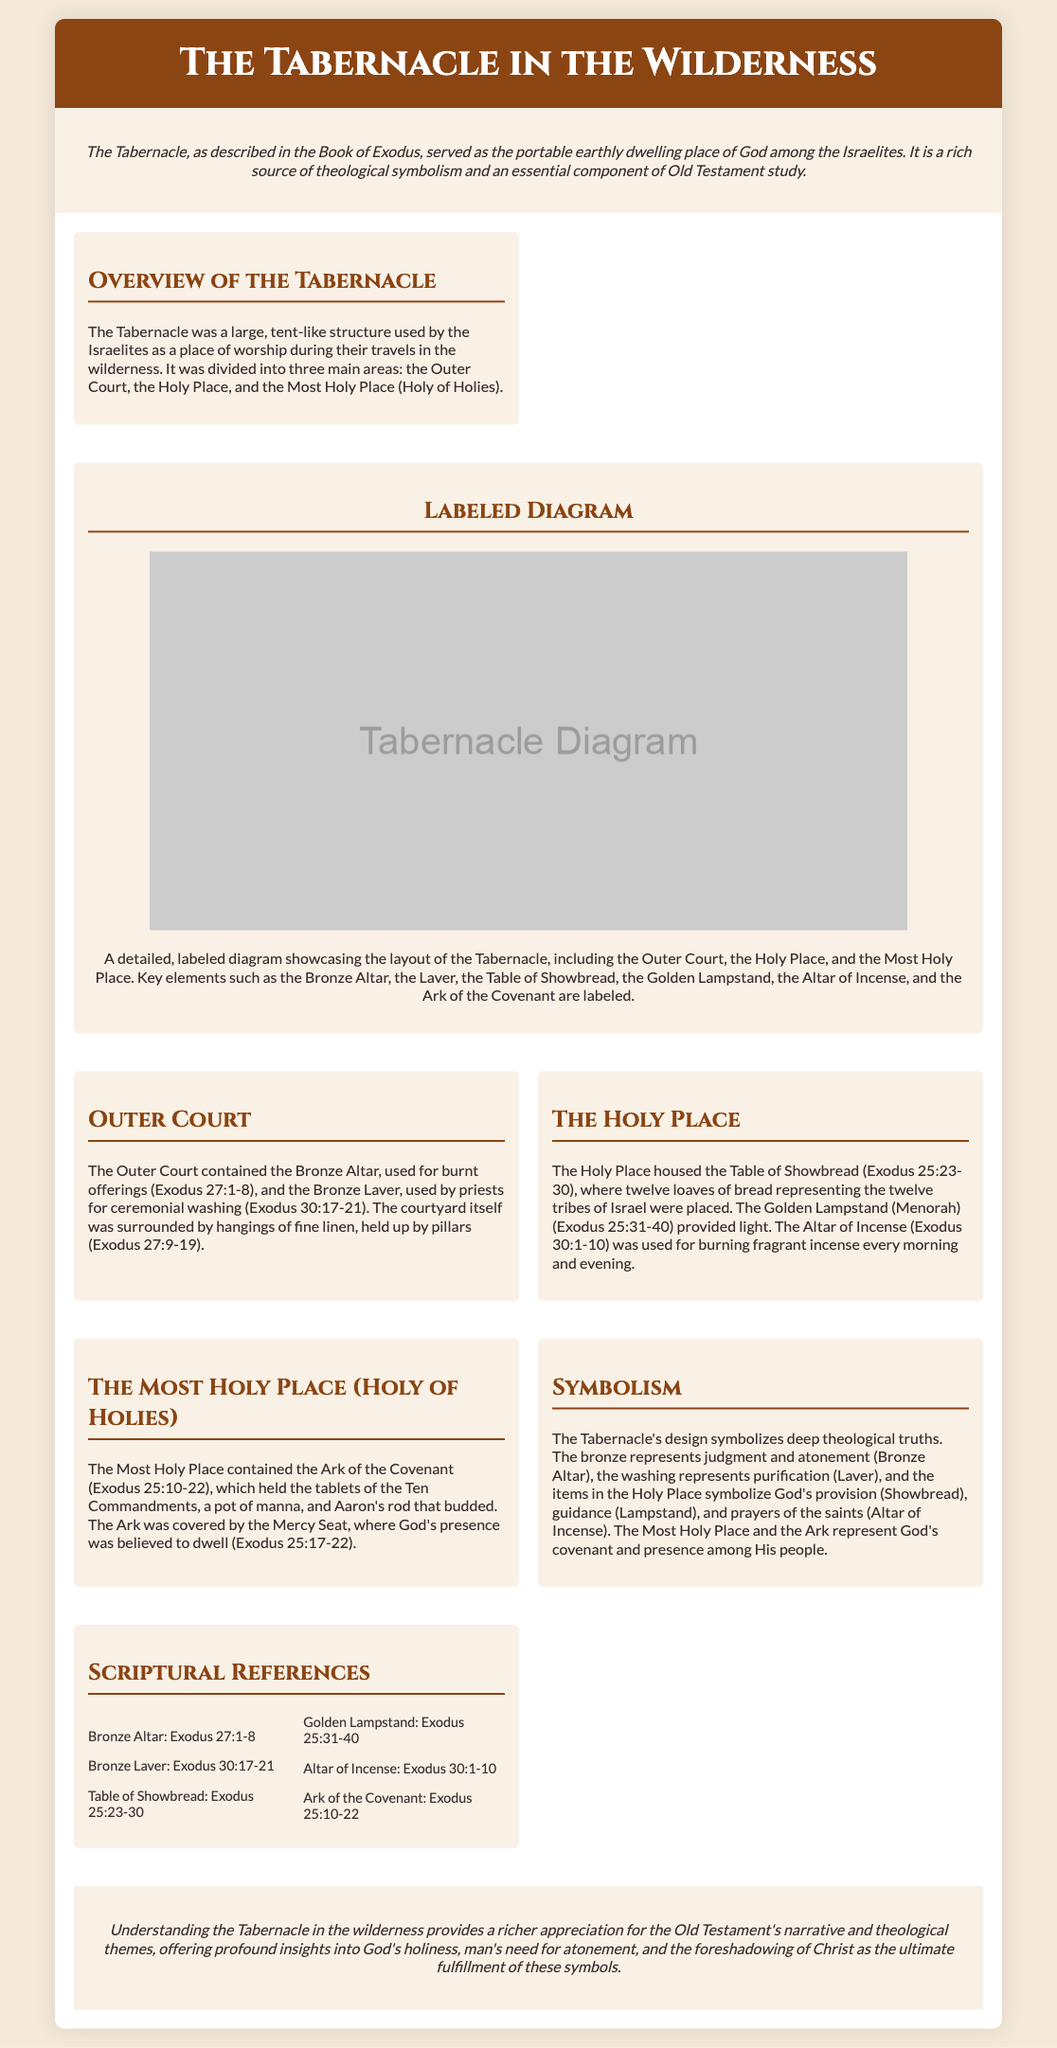What are the three main areas of the Tabernacle? The document states that the Tabernacle was divided into three main areas: the Outer Court, the Holy Place, and the Most Holy Place (Holy of Holies).
Answer: Outer Court, Holy Place, Most Holy Place What is the purpose of the Bronze Altar? The Bronze Altar is explicitly mentioned to be used for burnt offerings according to Exodus 27:1-8.
Answer: Burnt offerings What does the Ark of the Covenant contain? The document lists that the Ark of the Covenant held the tablets of the Ten Commandments, a pot of manna, and Aaron's rod that budded.
Answer: Tablets of the Ten Commandments, pot of manna, Aaron's rod What item provides light in the Holy Place? The document specifies that the Golden Lampstand (Menorah) provides light in the Holy Place as referenced in Exodus 25:31-40.
Answer: Golden Lampstand What does the Bronze Laver symbolize? The document describes that the washing at the Laver represents purification and connects to the priests' ceremonial washing in Exodus 30:17-21.
Answer: Purification Which chapter discusses the Altar of Incense? The document provides the reference for the Altar of Incense in Exodus, specifically chapter 30, verses 1-10.
Answer: Exodus 30:1-10 What is the function of the Table of Showbread? According to the document, the Table of Showbread is where twelve loaves of bread representing the twelve tribes of Israel were placed.
Answer: Twelve loaves of bread What does the Most Holy Place represent? The document explains that the Most Holy Place and the Ark represent God's covenant and presence among His people.
Answer: God's covenant and presence What type of document is this? The content and structure indicate that this is a schematic poster showcasing the design, function, and symbolism of the Tabernacle.
Answer: Schematic poster 